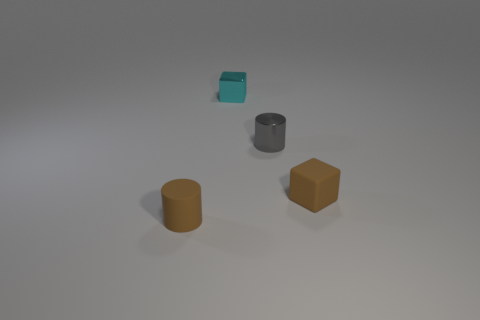Do the rubber block and the rubber cylinder have the same color? yes 